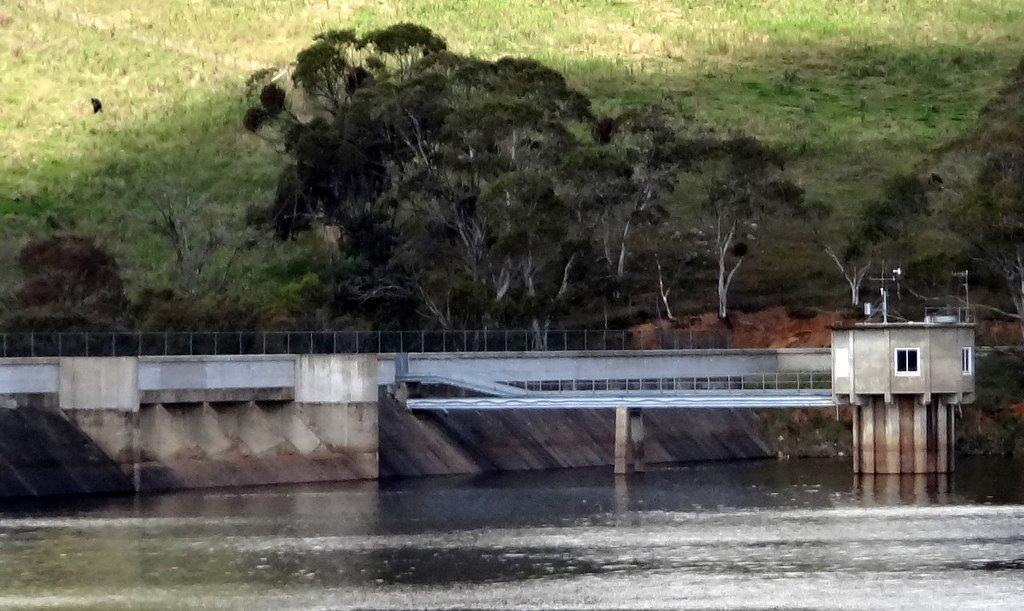What type of natural feature is present in the image? There is a river in the image. What other natural elements can be seen in the image? There are trees and plants in the image. Where is the cabin located in the image? The cabin is on the right side of the image. How many quince trees are growing near the cabin in the image? There are no quince trees present in the image. What adjustments need to be made to the cabin's roof in the image? There is no indication in the image that any adjustments need to be made to the cabin's roof. 